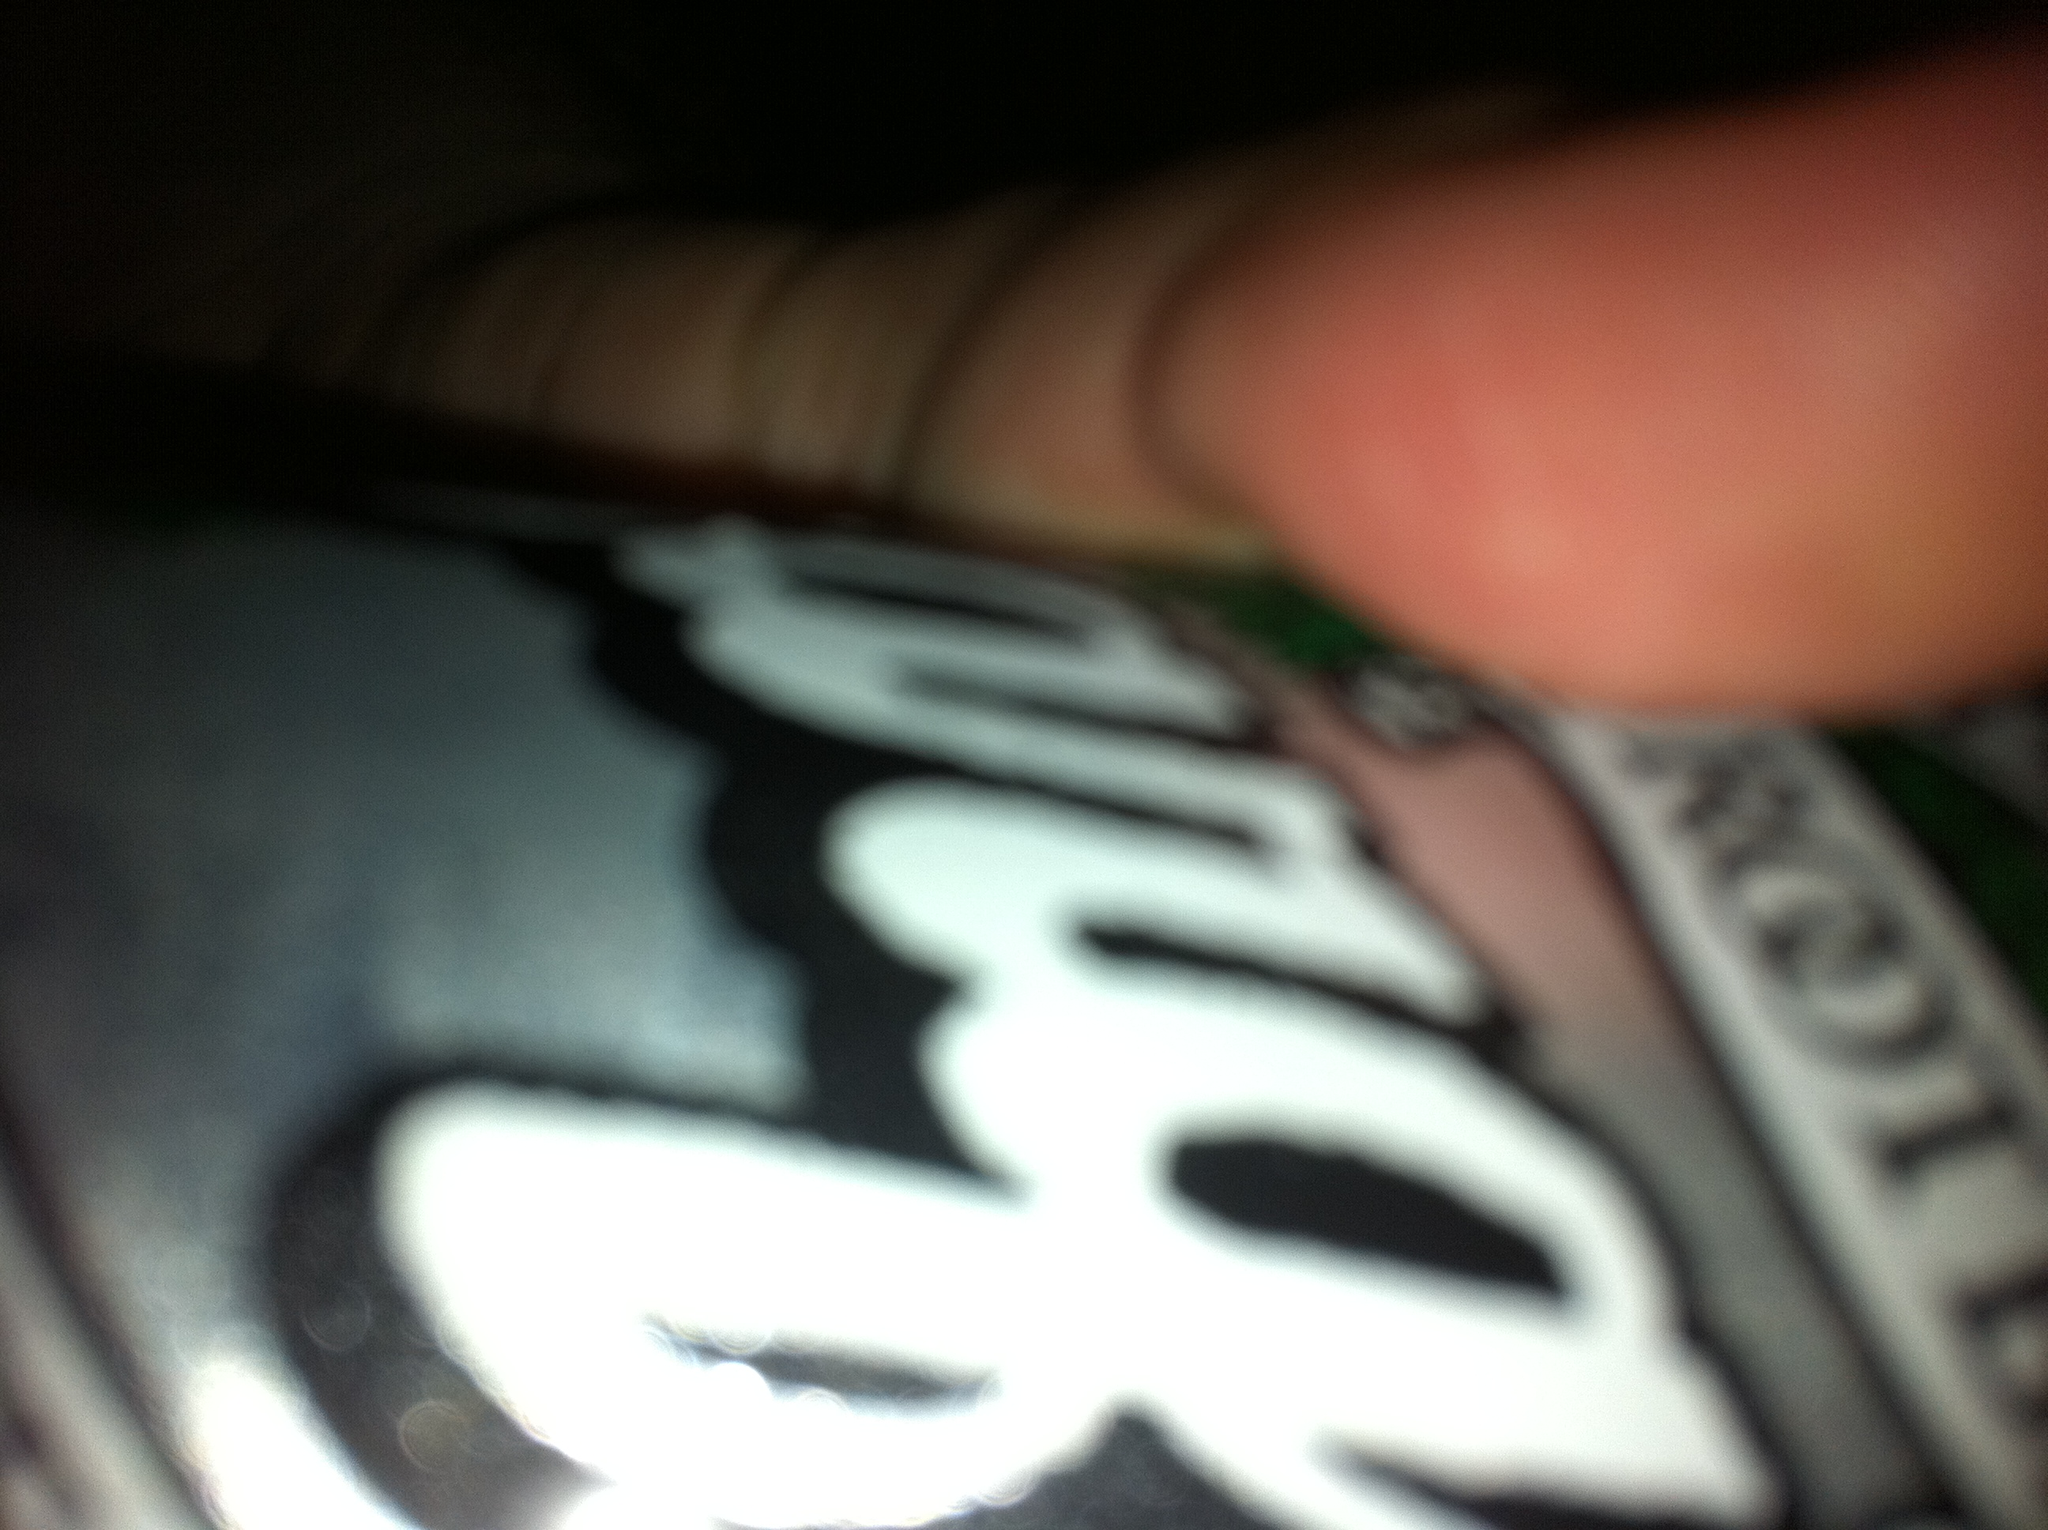What is a fun casual activity you can do with a friend involving root beer? A fun casual activity to enjoy with a friend involving root beer is to host a root beer taste testing party. Gather a selection of different root beer brands, including this one, and set up a taste-testing station. You can provide scorecards for each brand, noting the flavor, fizz, and overall enjoyment. Don’t forget to include tasty snacks like pretzels and popcorn to complement the root beer tasting experience! 